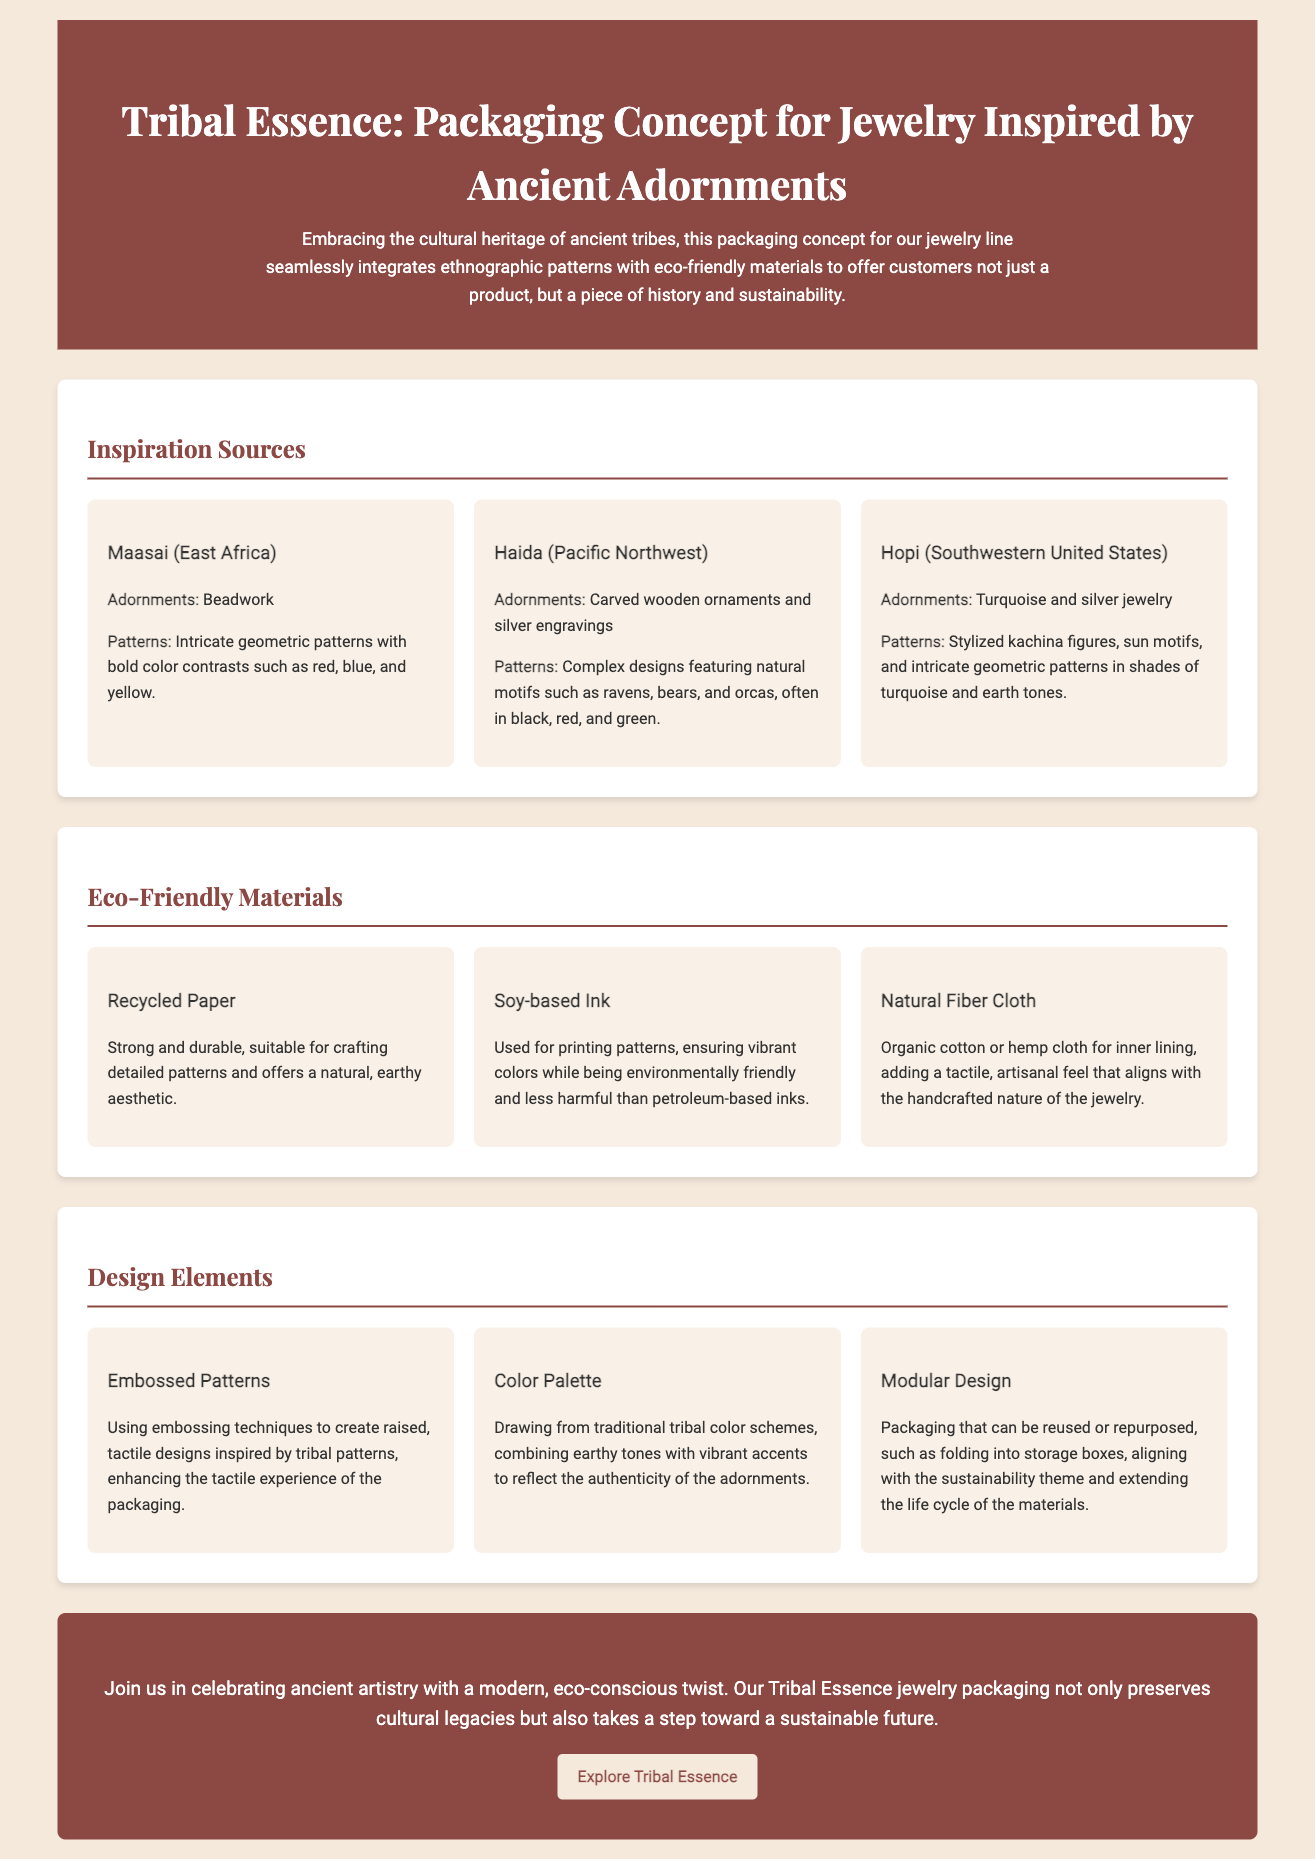What is the title of the packaging concept? The title of the packaging concept is presented prominently in the header section of the document.
Answer: Tribal Essence: Packaging Concept for Jewelry Inspired by Ancient Adornments What materials are used in the packaging? The document lists several eco-friendly materials utilized in the packaging, reflecting a commitment to sustainability.
Answer: Recycled Paper, Soy-based Ink, Natural Fiber Cloth Which tribal inspiration features intricate geometric patterns? The document names tribes that inspired the design; one tribe is highlighted for its specific pattern style that matches this description.
Answer: Maasai What colors are highlighted in the Haida inspiration? The Haida inspiration section details the colors commonly found in their adornments and patterns, which helps identify their aesthetic.
Answer: Black, red, and green What design element enhances the tactile experience? The document discusses various design elements, and one specifically targets the physical engagement with the packaging.
Answer: Embossed Patterns What type of design allows for repurposing? The document addresses sustainable practices in packaging design, narrows down to a specific design idea regarding usability after purchase.
Answer: Modular Design How many inspiration sources are mentioned? The document outlines several cultural inspirations, and a count of items should confirm the range covered in the document.
Answer: Three What is the color scheme inspired by? The document describes the foundation for choosing colors in the packaging design established from traditional practices.
Answer: Traditional tribal color schemes What is the overall theme of the packaging? The introduction discusses the core principles guiding the packaging concept, guiding the viewer's understanding of the product's intent.
Answer: Sustainability 